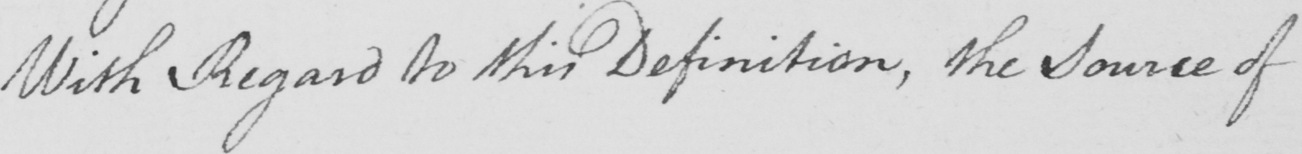What does this handwritten line say? With Regard to this Definition , the Source of 